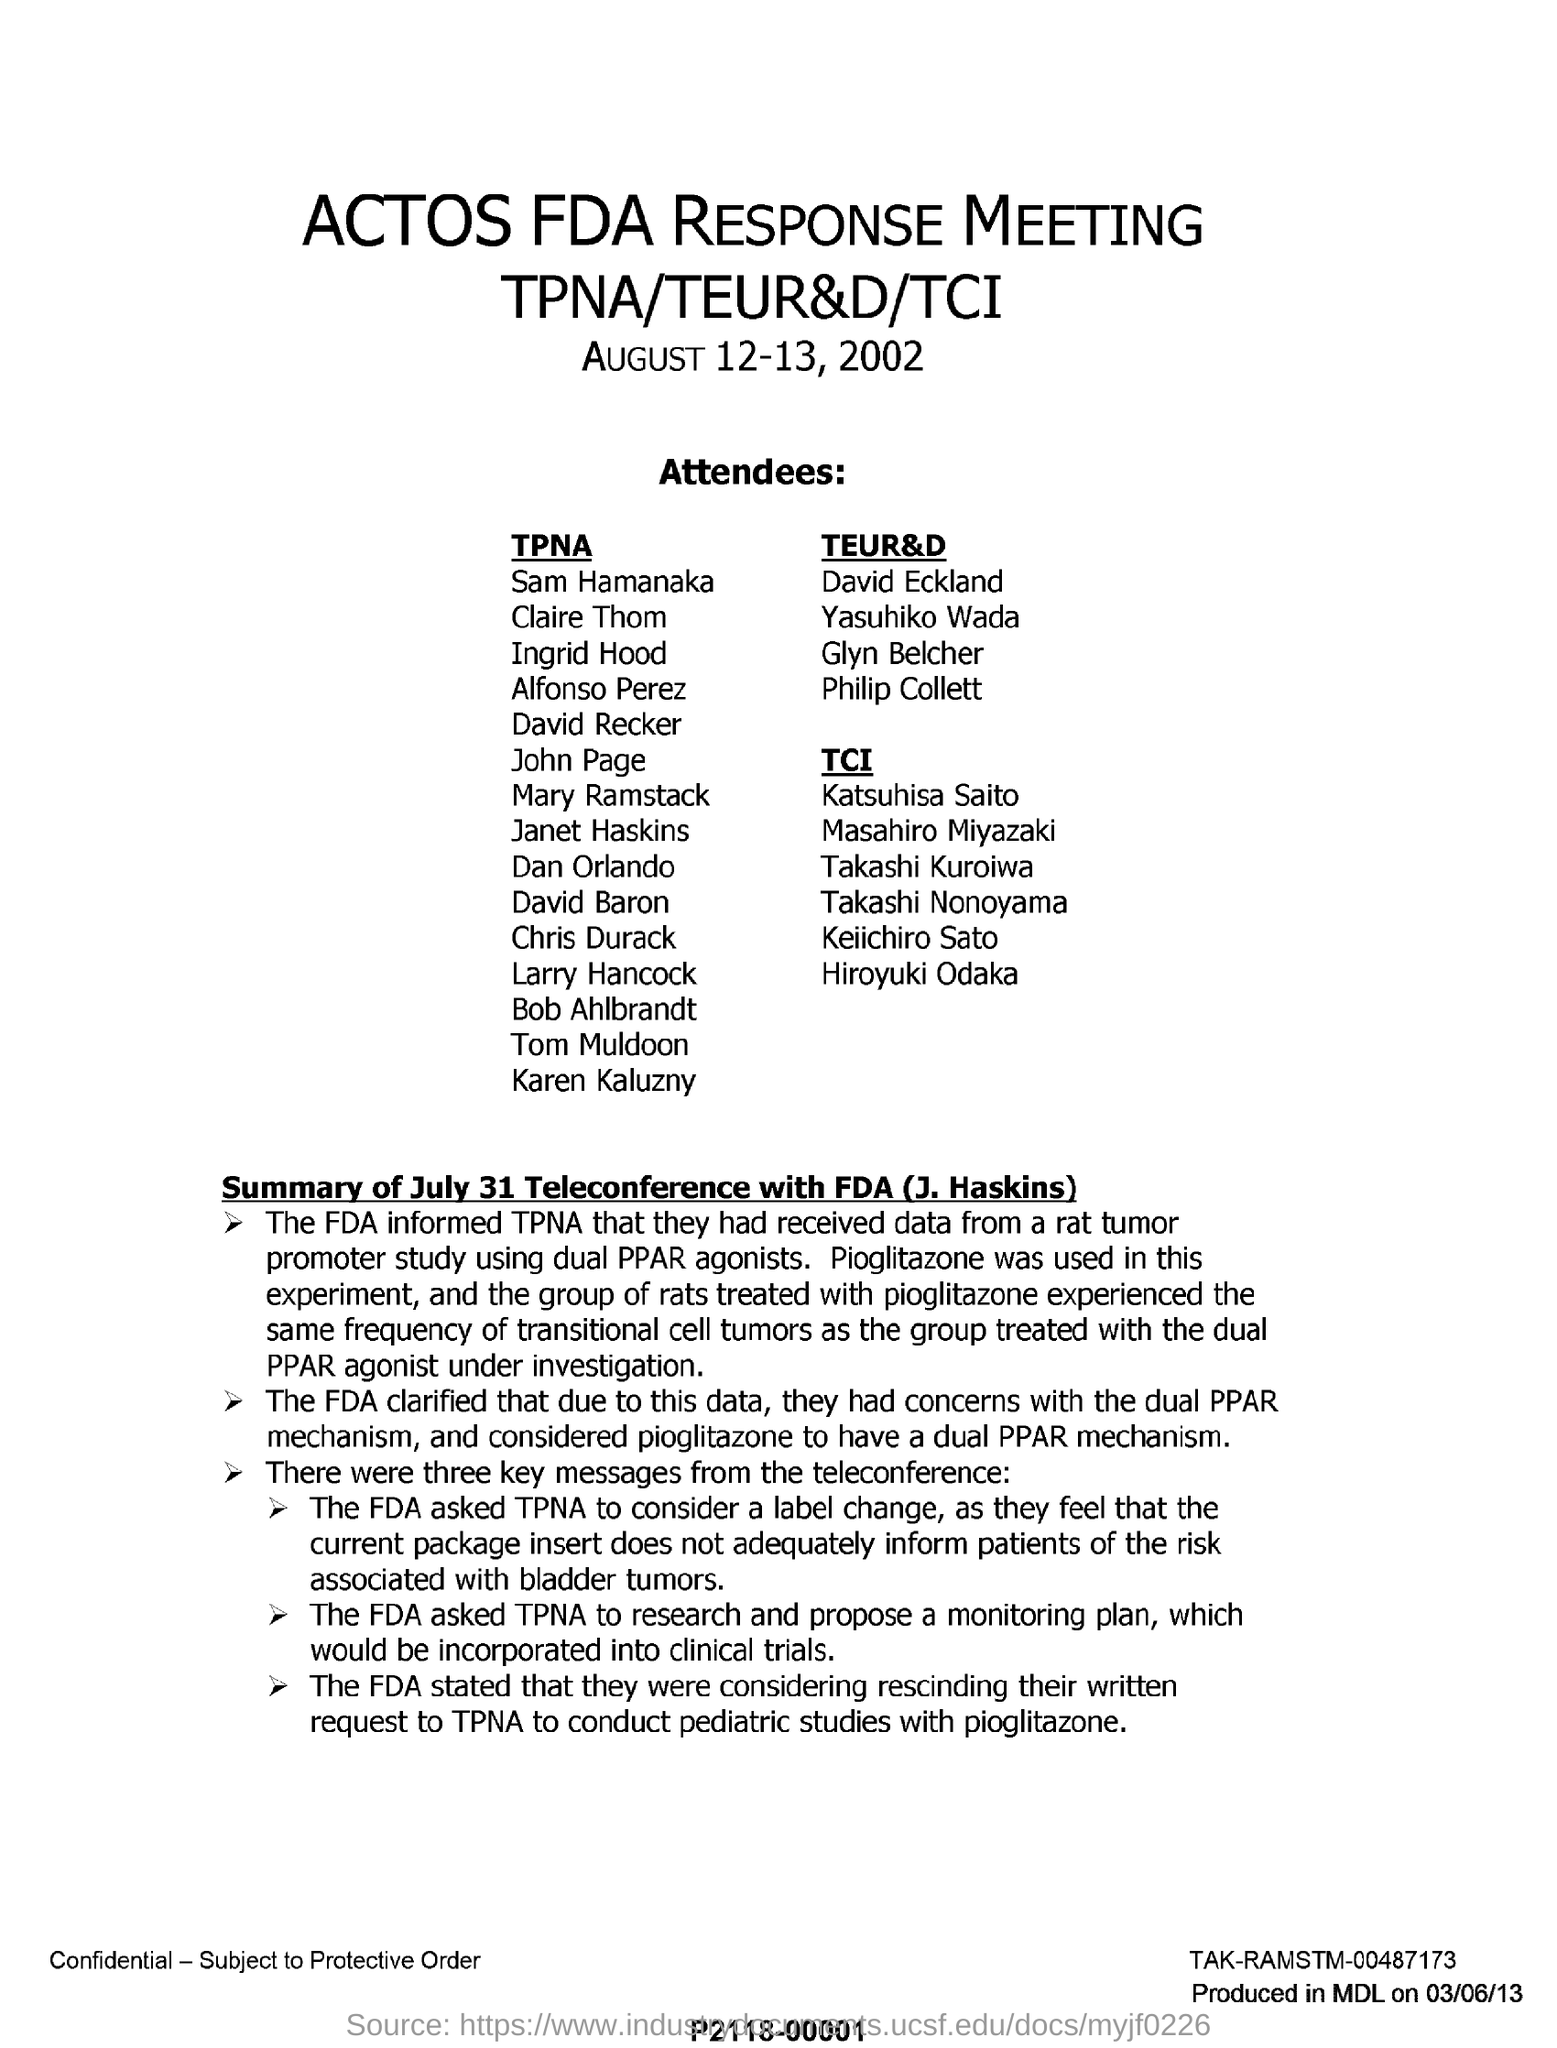Indicate a few pertinent items in this graphic. The drug used to treat the group of rats is pioglitazone. In a group of rats treated with pioglitazone, the frequency of cell tumors was the same as in a group of rats that did not receive the treatment. The letter mentions a meeting called an "ACTOS FDA Response Meeting. 